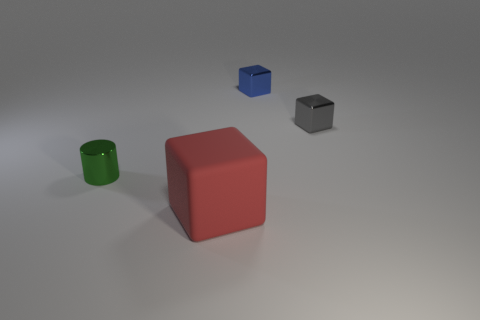Are there any other things that are made of the same material as the red object?
Provide a succinct answer. No. What size is the block in front of the small green shiny cylinder?
Provide a succinct answer. Large. There is a thing in front of the metal thing that is to the left of the block in front of the small green cylinder; what shape is it?
Make the answer very short. Cube. There is a object that is to the right of the small green object and to the left of the small blue metallic thing; what is its shape?
Provide a succinct answer. Cube. Are there any gray shiny blocks of the same size as the blue shiny cube?
Provide a succinct answer. Yes. There is a small shiny object behind the tiny gray object; does it have the same shape as the gray metallic object?
Keep it short and to the point. Yes. Does the matte object have the same shape as the blue metallic thing?
Offer a terse response. Yes. Is there a gray object that has the same shape as the red rubber thing?
Offer a terse response. Yes. What shape is the thing in front of the tiny metallic object that is to the left of the red rubber thing?
Offer a very short reply. Cube. There is a block that is in front of the tiny green cylinder; what is its color?
Keep it short and to the point. Red. 